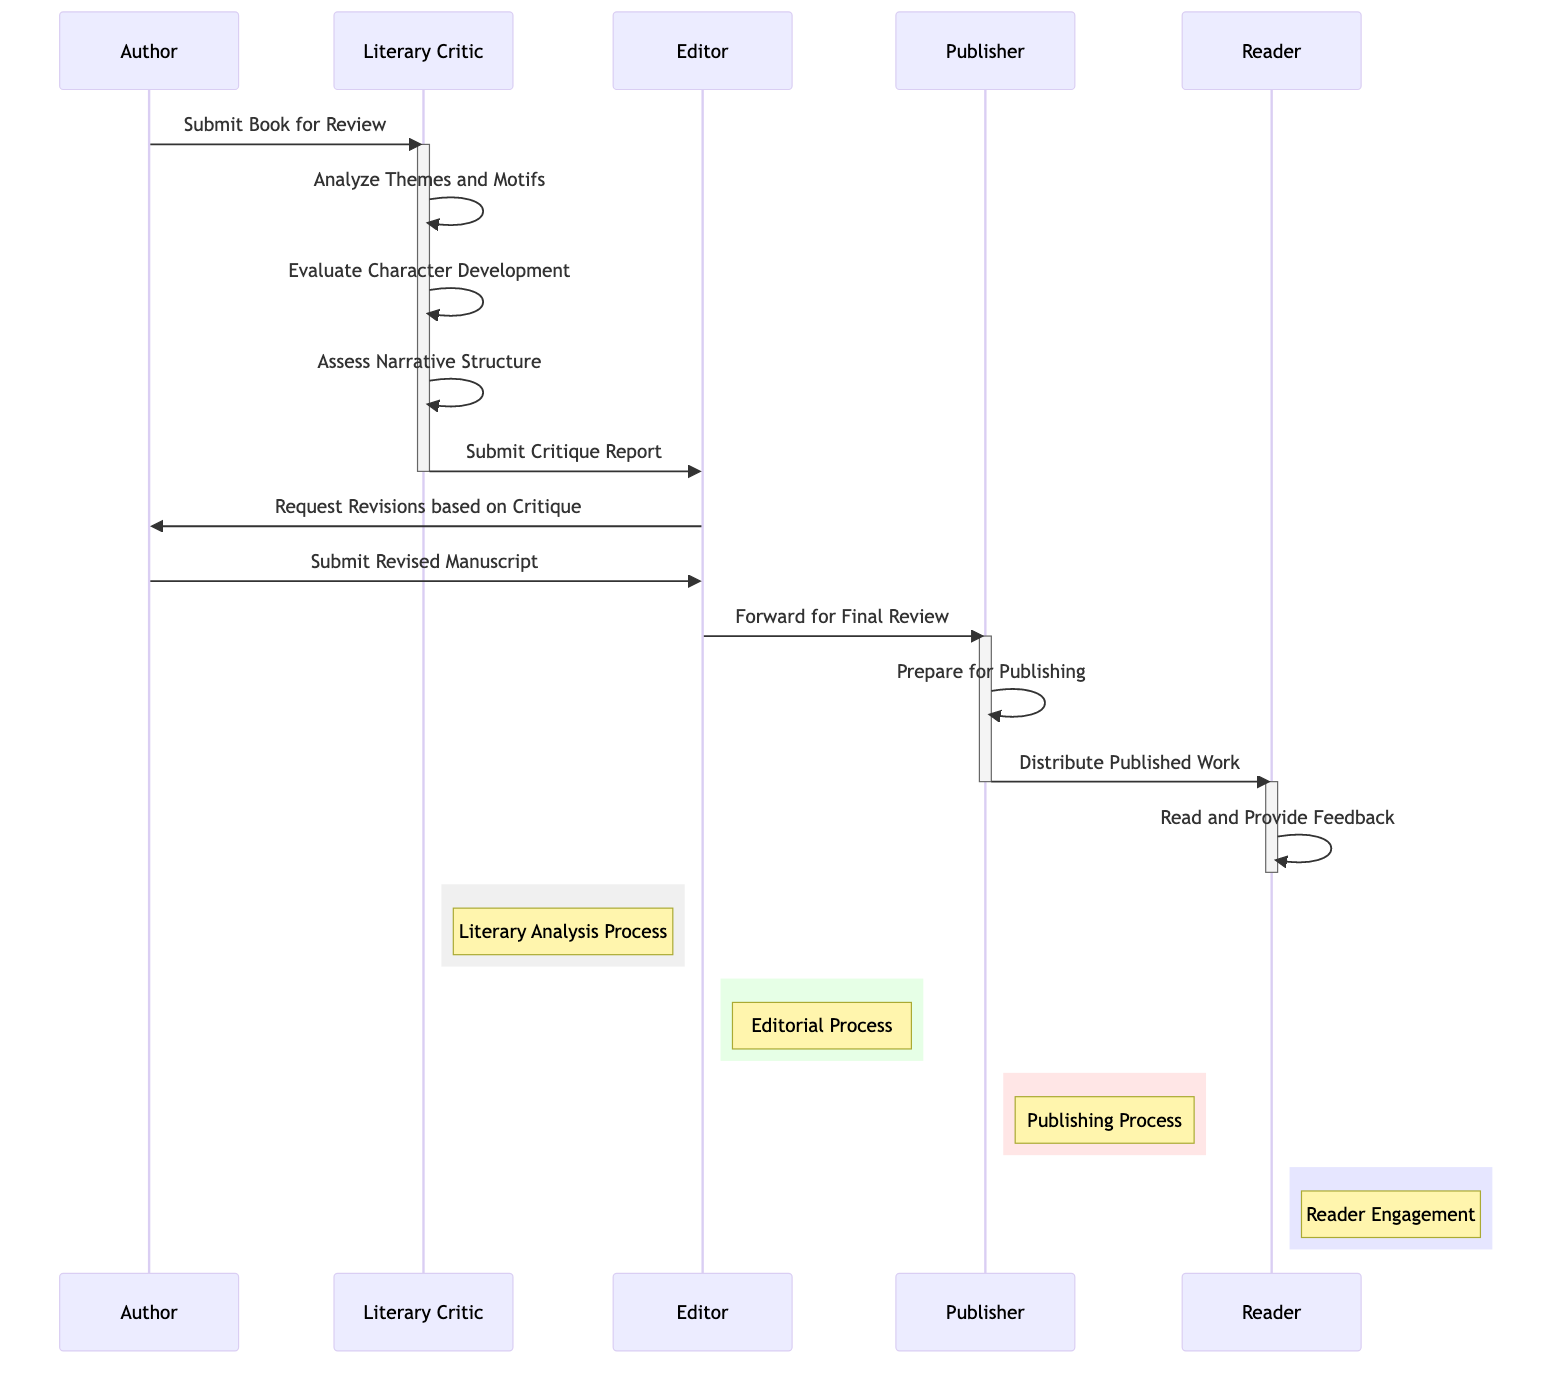What is the first action taken in the sequence? The first action in the sequence, as indicated in the diagram, is the Author submitting the book for review. This is evidenced by the message that starts from the Author pointing to the Literary Critic.
Answer: Submit Book for Review How many steps are there in the Literary Analysis Process? The Literary Analysis Process consists of three steps, each marked by a message from the Literary Critic to itself. These steps include analyzing themes and motifs, evaluating character development, and assessing narrative structure.
Answer: 3 Who does the Editor communicate with after submitting the critique report? After the Literary Critic submits the critique report to the Editor, the Editor then communicates with the Author to request revisions based on that critique. This is shown by a message from the Editor directed to the Author.
Answer: Author What step comes right before the Publisher prepares for publishing? The step that comes right before the Publisher prepares for publishing is when the Editor forwards the manuscript for final review to the Publisher. This is clearly shown in the sequence diagram as a direct message from the Editor to the Publisher.
Answer: Forward for Final Review Which participant is responsible for distributing the published work? The Publisher is responsible for distributing the published work, as indicated by the message from the Publisher to the Reader in the diagram. This clearly defines the distribution role in the sequence.
Answer: Publisher In which part of the diagram does the Reader engage with the published work? The Reader engages with the published work in the Reader Engagement section of the diagram. This is where the Reader reads and provides feedback, as indicated by the self-message from the Reader to itself.
Answer: Reader Engagement How many actors are involved in this sequence? The sequence involves five actors, which are the Author, Literary Critic, Editor, Publisher, and Reader. Each actor is represented clearly at the top of the diagram.
Answer: 5 What action follows the submission of the revised manuscript? Following the submission of the revised manuscript, the next action taken is the Editor forwarding it for final review to the Publisher. This flow is captured in the sequence of messages in the diagram.
Answer: Forward for Final Review 